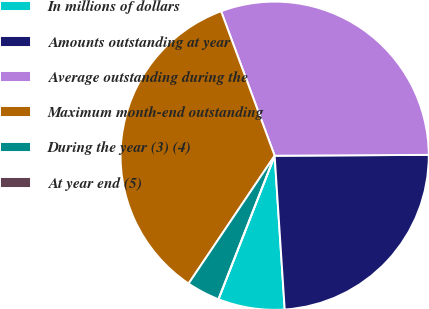Convert chart. <chart><loc_0><loc_0><loc_500><loc_500><pie_chart><fcel>In millions of dollars<fcel>Amounts outstanding at year<fcel>Average outstanding during the<fcel>Maximum month-end outstanding<fcel>During the year (3) (4)<fcel>At year end (5)<nl><fcel>6.98%<fcel>24.05%<fcel>30.56%<fcel>34.92%<fcel>3.49%<fcel>0.0%<nl></chart> 